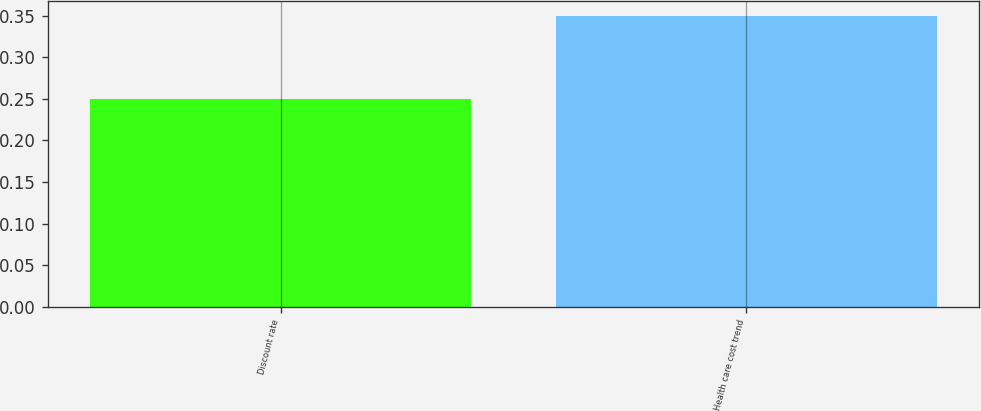Convert chart to OTSL. <chart><loc_0><loc_0><loc_500><loc_500><bar_chart><fcel>Discount rate<fcel>Health care cost trend<nl><fcel>0.25<fcel>0.35<nl></chart> 